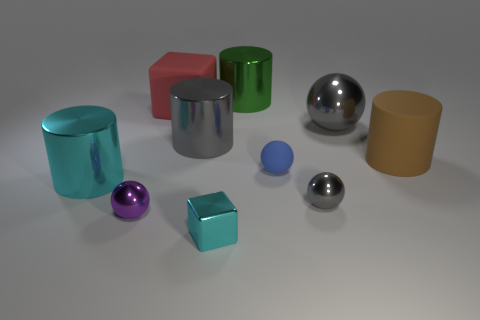Subtract all cubes. How many objects are left? 8 Subtract 0 green spheres. How many objects are left? 10 Subtract all gray shiny balls. Subtract all purple rubber cylinders. How many objects are left? 8 Add 1 large cyan cylinders. How many large cyan cylinders are left? 2 Add 1 red matte things. How many red matte things exist? 2 